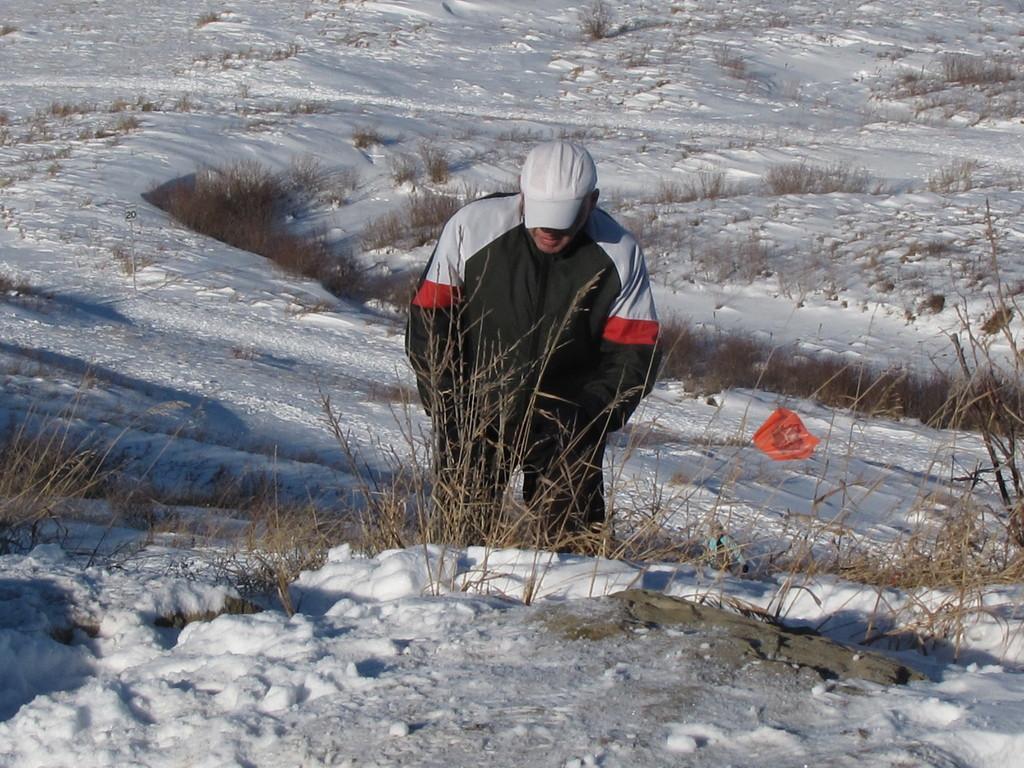Describe this image in one or two sentences. There is a man wearing a cap. On the ground there is snow and plants. 